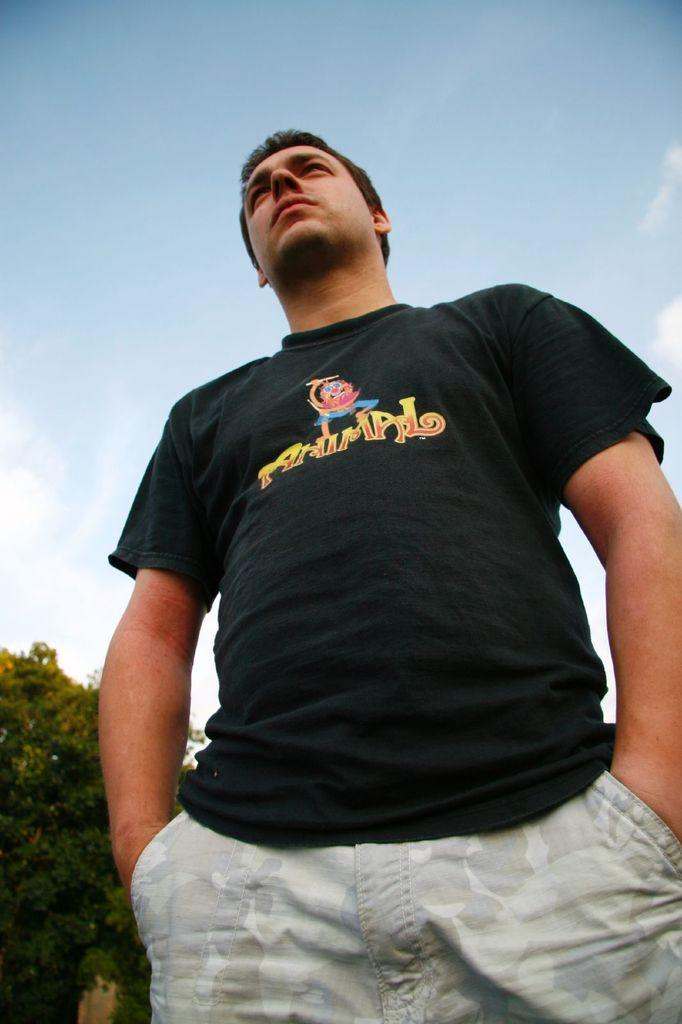What is the main subject of the image? There is a person standing in the image. What is the person wearing? The person is wearing a black T-shirt. What can be seen in the sky in the image? Clouds are visible in the sky. What type of vegetation is present in the image? Trees are present in the image. How many mouths can be seen on the person in the image? There is only one person in the image, and they have one mouth. What type of quiver is the person holding in the image? There is no quiver present in the image; the person is simply standing and wearing a black T-shirt. 